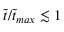<formula> <loc_0><loc_0><loc_500><loc_500>\tilde { t } / \tilde { t } _ { \max } \lesssim 1</formula> 